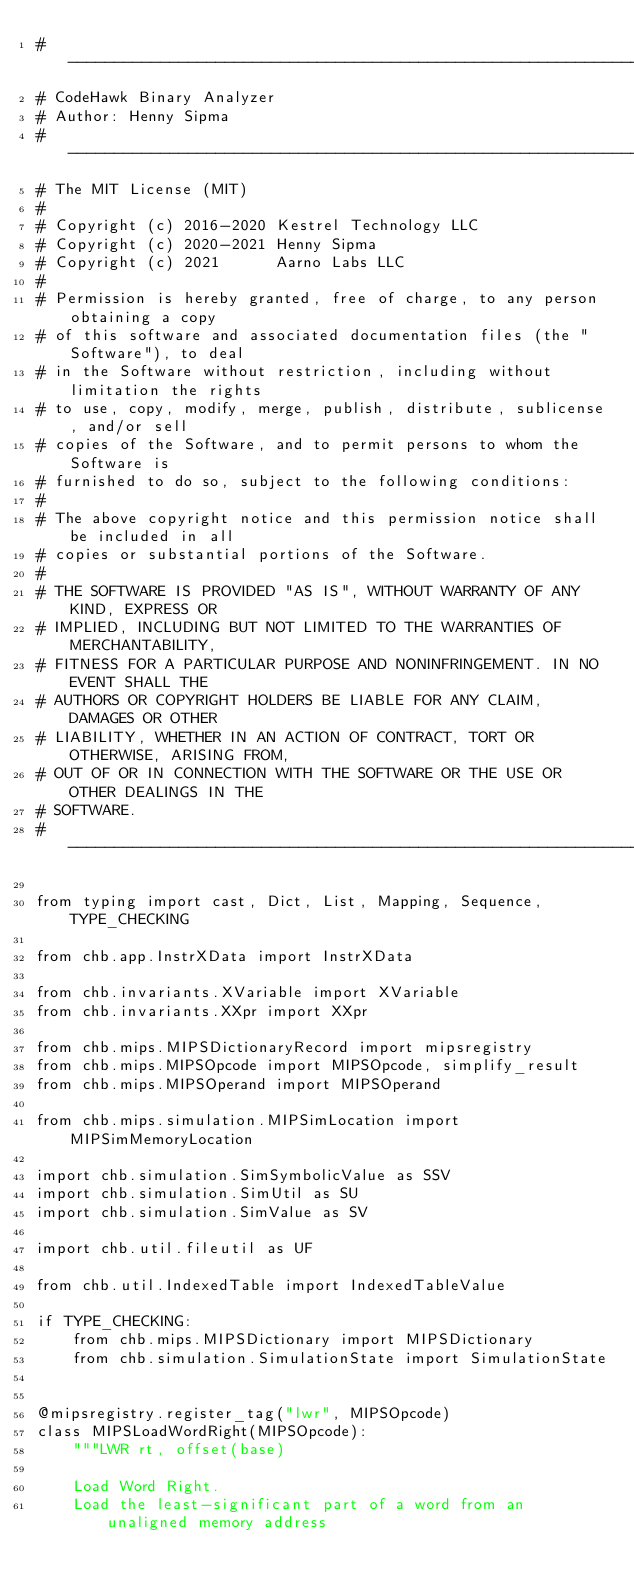Convert code to text. <code><loc_0><loc_0><loc_500><loc_500><_Python_># ------------------------------------------------------------------------------
# CodeHawk Binary Analyzer
# Author: Henny Sipma
# ------------------------------------------------------------------------------
# The MIT License (MIT)
#
# Copyright (c) 2016-2020 Kestrel Technology LLC
# Copyright (c) 2020-2021 Henny Sipma
# Copyright (c) 2021      Aarno Labs LLC
#
# Permission is hereby granted, free of charge, to any person obtaining a copy
# of this software and associated documentation files (the "Software"), to deal
# in the Software without restriction, including without limitation the rights
# to use, copy, modify, merge, publish, distribute, sublicense, and/or sell
# copies of the Software, and to permit persons to whom the Software is
# furnished to do so, subject to the following conditions:
#
# The above copyright notice and this permission notice shall be included in all
# copies or substantial portions of the Software.
#
# THE SOFTWARE IS PROVIDED "AS IS", WITHOUT WARRANTY OF ANY KIND, EXPRESS OR
# IMPLIED, INCLUDING BUT NOT LIMITED TO THE WARRANTIES OF MERCHANTABILITY,
# FITNESS FOR A PARTICULAR PURPOSE AND NONINFRINGEMENT. IN NO EVENT SHALL THE
# AUTHORS OR COPYRIGHT HOLDERS BE LIABLE FOR ANY CLAIM, DAMAGES OR OTHER
# LIABILITY, WHETHER IN AN ACTION OF CONTRACT, TORT OR OTHERWISE, ARISING FROM,
# OUT OF OR IN CONNECTION WITH THE SOFTWARE OR THE USE OR OTHER DEALINGS IN THE
# SOFTWARE.
# ------------------------------------------------------------------------------

from typing import cast, Dict, List, Mapping, Sequence, TYPE_CHECKING

from chb.app.InstrXData import InstrXData

from chb.invariants.XVariable import XVariable
from chb.invariants.XXpr import XXpr

from chb.mips.MIPSDictionaryRecord import mipsregistry
from chb.mips.MIPSOpcode import MIPSOpcode, simplify_result
from chb.mips.MIPSOperand import MIPSOperand

from chb.mips.simulation.MIPSimLocation import MIPSimMemoryLocation

import chb.simulation.SimSymbolicValue as SSV
import chb.simulation.SimUtil as SU
import chb.simulation.SimValue as SV

import chb.util.fileutil as UF

from chb.util.IndexedTable import IndexedTableValue

if TYPE_CHECKING:
    from chb.mips.MIPSDictionary import MIPSDictionary
    from chb.simulation.SimulationState import SimulationState


@mipsregistry.register_tag("lwr", MIPSOpcode)
class MIPSLoadWordRight(MIPSOpcode):
    """LWR rt, offset(base)

    Load Word Right.
    Load the least-significant part of a word from an unaligned memory address</code> 